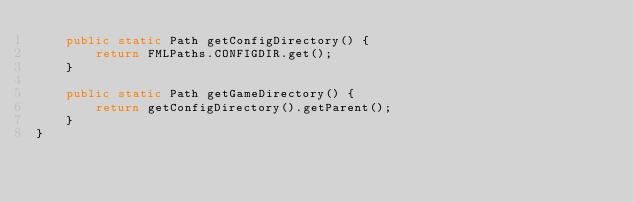<code> <loc_0><loc_0><loc_500><loc_500><_Java_>    public static Path getConfigDirectory() {
        return FMLPaths.CONFIGDIR.get();
    }

    public static Path getGameDirectory() {
        return getConfigDirectory().getParent();
    }
}
</code> 